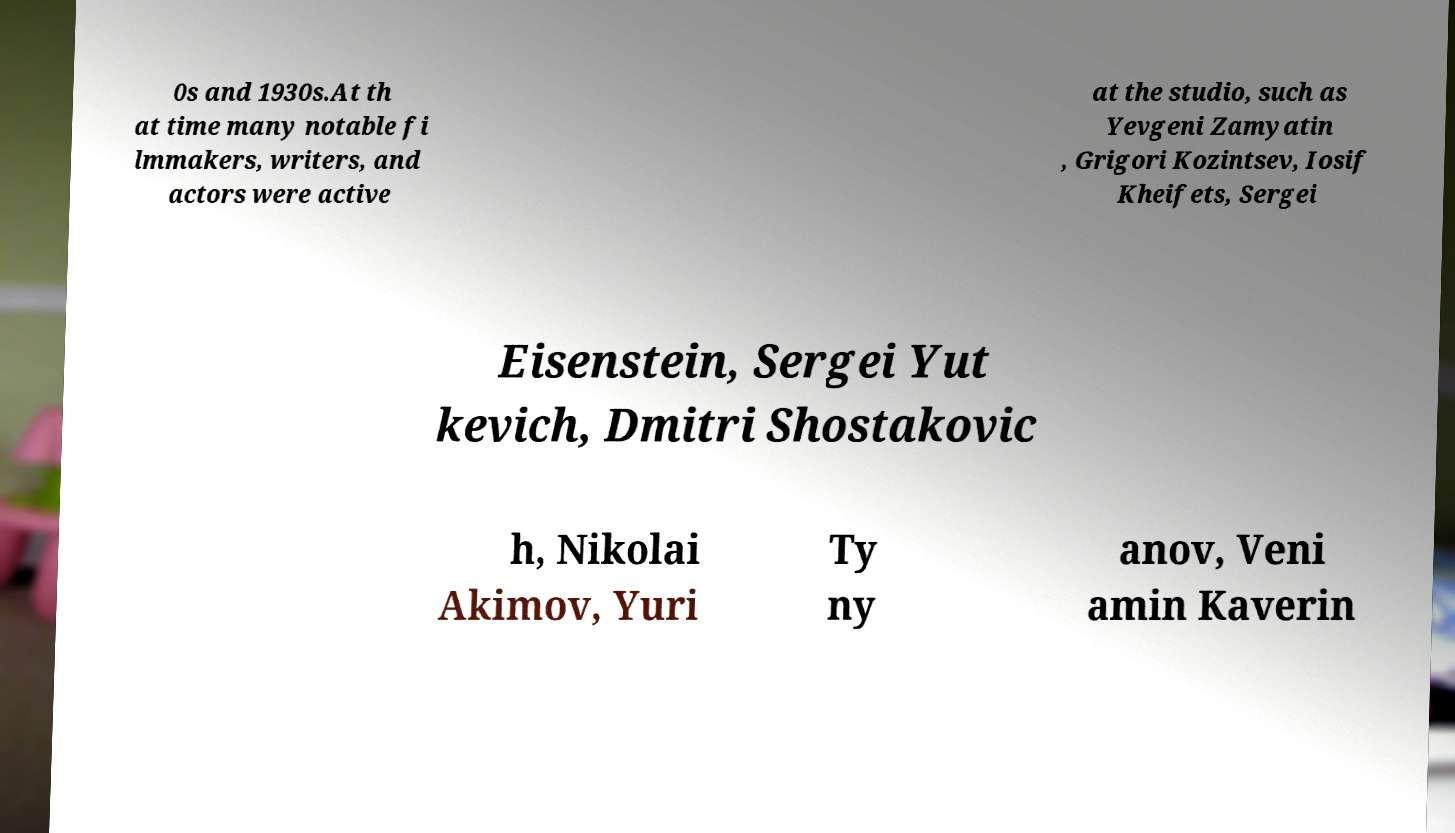Can you accurately transcribe the text from the provided image for me? 0s and 1930s.At th at time many notable fi lmmakers, writers, and actors were active at the studio, such as Yevgeni Zamyatin , Grigori Kozintsev, Iosif Kheifets, Sergei Eisenstein, Sergei Yut kevich, Dmitri Shostakovic h, Nikolai Akimov, Yuri Ty ny anov, Veni amin Kaverin 